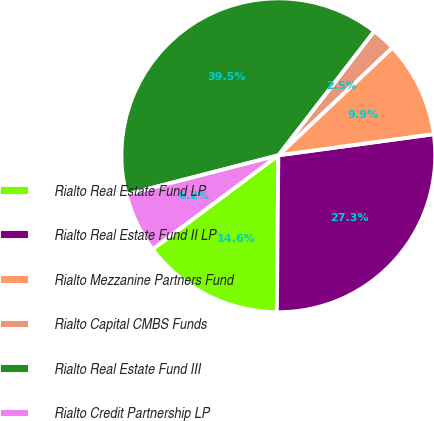<chart> <loc_0><loc_0><loc_500><loc_500><pie_chart><fcel>Rialto Real Estate Fund LP<fcel>Rialto Real Estate Fund II LP<fcel>Rialto Mezzanine Partners Fund<fcel>Rialto Capital CMBS Funds<fcel>Rialto Real Estate Fund III<fcel>Rialto Credit Partnership LP<nl><fcel>14.64%<fcel>27.3%<fcel>9.89%<fcel>2.49%<fcel>39.48%<fcel>6.19%<nl></chart> 